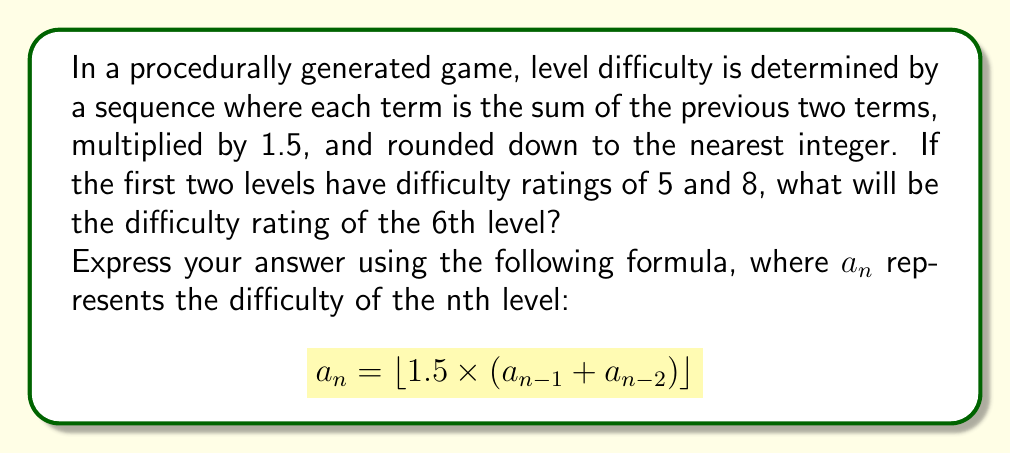Could you help me with this problem? Let's calculate the difficulty ratings step by step:

1. Given: $a_1 = 5$ and $a_2 = 8$

2. For $a_3$:
   $$a_3 = \lfloor 1.5 \times (8 + 5) \rfloor = \lfloor 1.5 \times 13 \rfloor = \lfloor 19.5 \rfloor = 19$$

3. For $a_4$:
   $$a_4 = \lfloor 1.5 \times (19 + 8) \rfloor = \lfloor 1.5 \times 27 \rfloor = \lfloor 40.5 \rfloor = 40$$

4. For $a_5$:
   $$a_5 = \lfloor 1.5 \times (40 + 19) \rfloor = \lfloor 1.5 \times 59 \rfloor = \lfloor 88.5 \rfloor = 88$$

5. Finally, for $a_6$:
   $$a_6 = \lfloor 1.5 \times (88 + 40) \rfloor = \lfloor 1.5 \times 128 \rfloor = \lfloor 192 \rfloor = 192$$

Therefore, the difficulty rating of the 6th level will be 192.
Answer: 192 